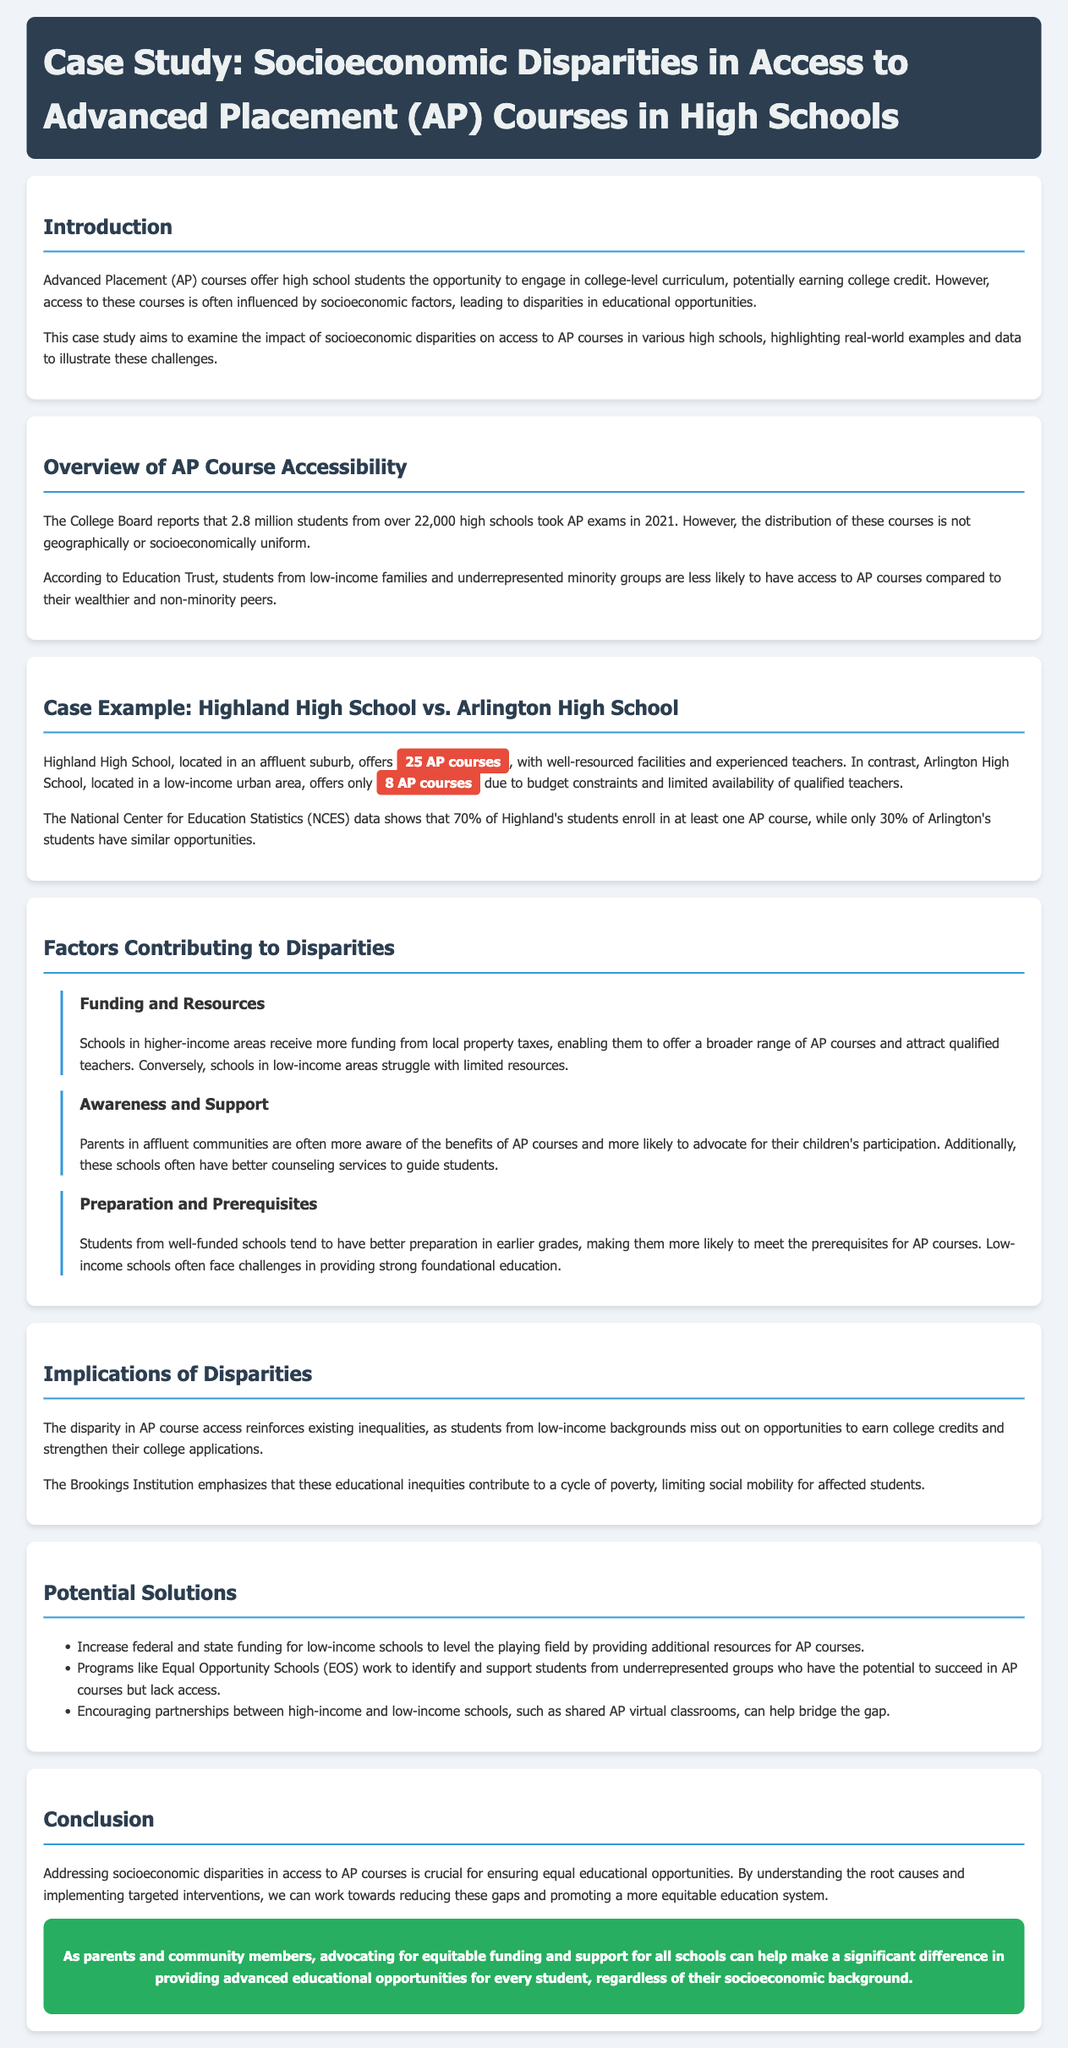What percentage of Highland's students enroll in at least one AP course? The document states that 70% of Highland's students enroll in at least one AP course, providing specific data on enrollment.
Answer: 70% How many AP courses does Arlington High School offer? The case example mentions that Arlington High School offers only 8 AP courses due to budget constraints.
Answer: 8 What is the primary reason for disparities in AP access according to the document? The document identifies funding and resources as a crucial factor contributing to disparities in AP course access.
Answer: Funding and resources Which organization emphasizes the cycle of poverty due to educational inequities? The Brookings Institution is mentioned in the implications section as emphasizing the cycle of poverty related to educational inequalities.
Answer: Brookings Institution What solution involves partnerships between different schools? The document suggests encouraging partnerships, such as shared AP virtual classrooms, to help bridge the gap between high-income and low-income schools.
Answer: Shared AP virtual classrooms What is the total number of AP exams taken in 2021? The document notes that 2.8 million students took AP exams in 2021, providing specific data on participation in AP courses.
Answer: 2.8 million What type of support do affluent communities have for AP participation? The document mentions that parents in affluent communities are more likely to advocate for their children's participation in AP courses.
Answer: Advocate for participation What are the potential solutions listed in the document? The document lists several solutions, including increasing funding for low-income schools and supporting underrepresented students through programs.
Answer: Increase funding and support programs 